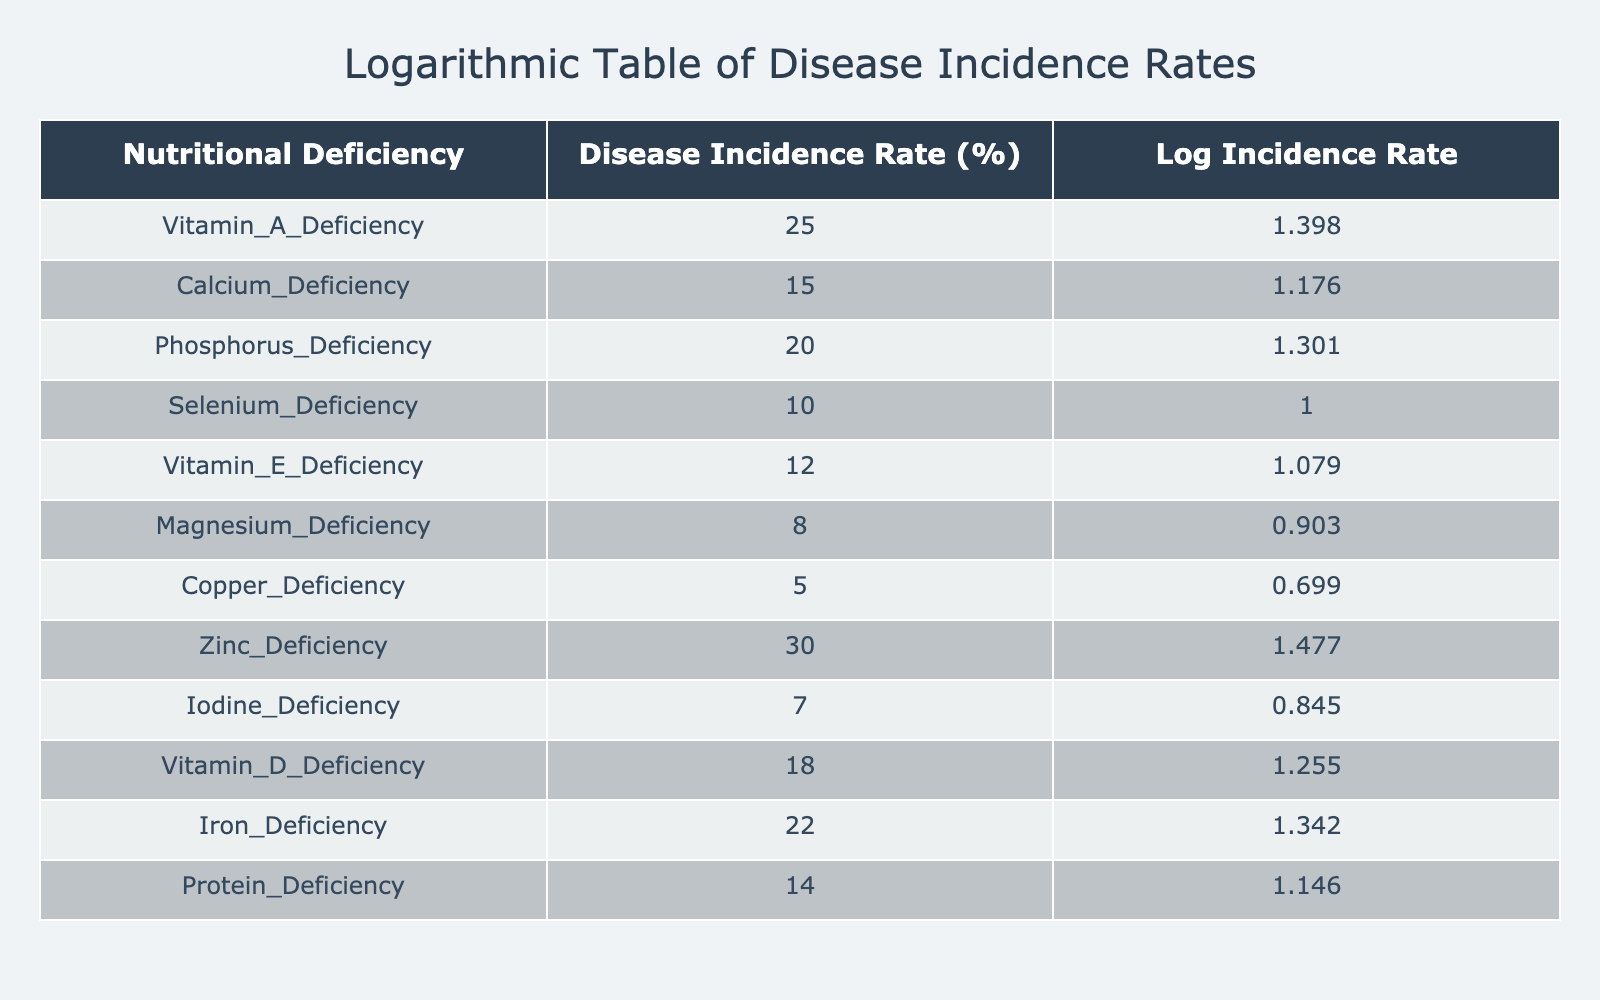What is the disease incidence rate for Vitamin A Deficiency? The table directly lists the disease incidence rates; for Vitamin A Deficiency, the corresponding value is 25%.
Answer: 25% Which nutritional deficiency has the highest disease incidence rate? By reviewing the incidence rates in the table, Zinc Deficiency has the highest rate at 30%.
Answer: Zinc Deficiency What is the combined disease incidence rate of Calcium and Magnesium Deficiencies? The individual rates are 15% for Calcium Deficiency and 8% for Magnesium Deficiency. Adding these gives 15 + 8 = 23%.
Answer: 23% Is the disease incidence rate for Iodine Deficiency greater than that for Copper Deficiency? The table shows Iodine Deficiency at 7% and Copper Deficiency at 5%. Since 7% is greater than 5%, the answer is yes.
Answer: Yes What is the average disease incidence rate for the nutritional deficiencies listed in the table? To find the average, sum all incidence rates: 25 + 15 + 20 + 10 + 12 + 8 + 5 + 30 + 7 + 18 + 22 + 14 =  255. Dividing by 12 (the number of deficiencies) gives 255 / 12 = 21.25%.
Answer: 21.25% Which vitamin deficiency has a disease incidence rate that is higher than both Vitamin E and Selenium Deficiencies? The table shows Vitamin E Deficiency at 12% and Selenium Deficiency at 10%. Looking at other deficiencies, Iron Deficiency at 22% is higher than both, meeting the criteria.
Answer: Iron Deficiency Is the logarithmic transformed incidence rate for Protein Deficiency higher than that of Calcium Deficiency? The logarithmic value of Protein Deficiency (14%) is calculated as log10(14) which is approximately 1.146. For Calcium Deficiency (15%), log10(15) is approximately 1.176. Since 1.146 is less than 1.176, the answer is no.
Answer: No Identify the two nutritional deficiencies with the lowest disease incidence rates. From the table, Copper Deficiency (5%) and Magnesium Deficiency (8%) have the lowest rates; they can be identified directly through comparison.
Answer: Copper and Magnesium Deficiencies 